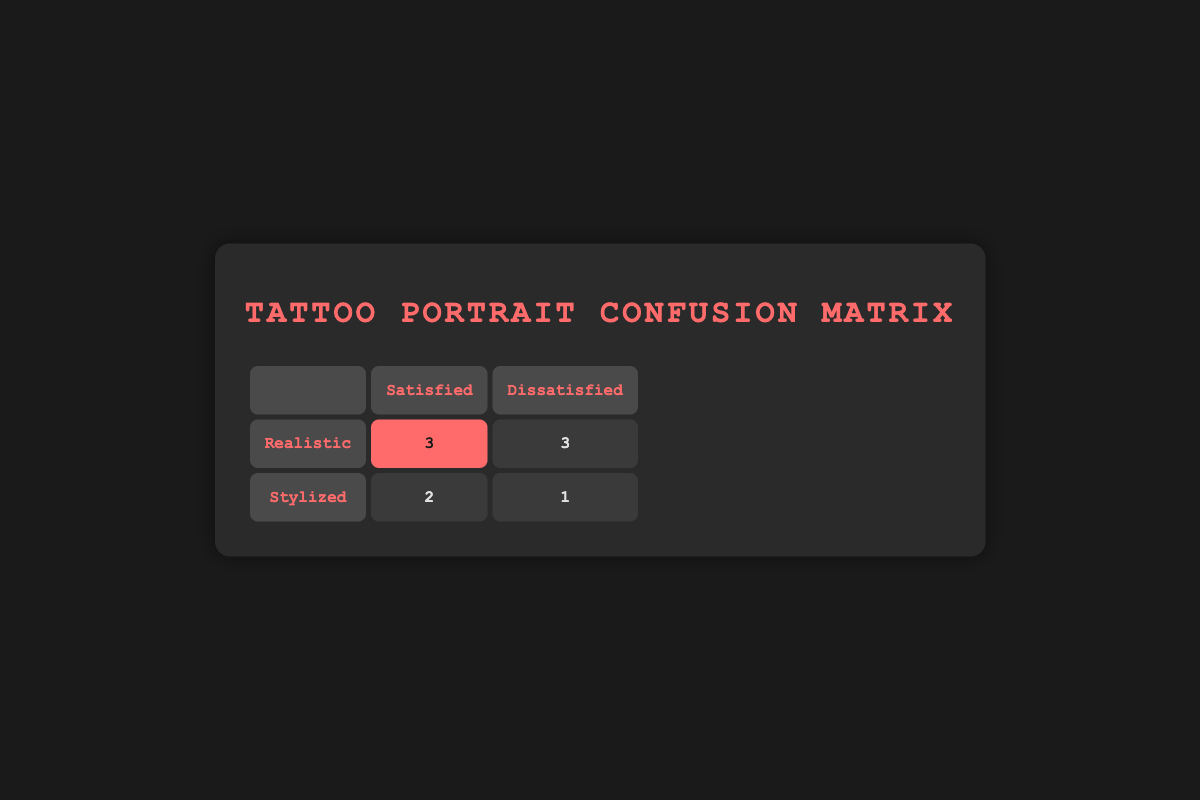What is the number of clients who expected a realistic portrait and were satisfied? Looking at the 'Realistic' row under the 'Satisfied' column, there are 3 clients listed.
Answer: 3 How many clients were dissatisfied with a stylized portrait? Under the 'Stylized' row and 'Dissatisfied' column, there is 1 client.
Answer: 1 What is the total number of clients who received a realistic portrait? The 'Realistic' row has a total of 6 clients: 3 satisfied and 3 dissatisfied.
Answer: 6 Is it true that more clients were satisfied with stylized portraits than dissatisfied? There are 2 satisfied clients and 1 dissatisfied client for stylized portraits, making it true.
Answer: Yes What is the difference between the number of satisfied and dissatisfied clients for realistic portraits? The number of satisfied clients for realistic portraits is 3, and the number of dissatisfied is also 3, so the difference is 3 - 3 = 0.
Answer: 0 How many clients were satisfied in total? To find this, we sum the satisfied clients from both styles: 3 (realistic) + 2 (stylized) = 5.
Answer: 5 Which expectation had the highest number of satisfied clients? The table indicates that the realistic expectation has 3 satisfied clients, while stylized has 2, thus realistic has more.
Answer: Realistic If we look only at dissatisfied clients, how many expected a realistic portrait? There are 3 clients listed under the 'Realistic' row in the 'Dissatisfied' column.
Answer: 3 What percentage of clients expecting a stylized portrait were satisfied? There are 2 satisfied clients out of 3 total (2 satisfied and 1 dissatisfied), so the percentage is (2/3) * 100 ≈ 66.67%.
Answer: 66.67% 